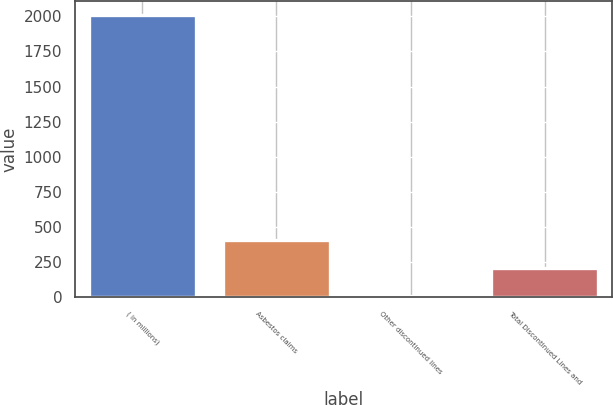Convert chart. <chart><loc_0><loc_0><loc_500><loc_500><bar_chart><fcel>( in millions)<fcel>Asbestos claims<fcel>Other discontinued lines<fcel>Total Discontinued Lines and<nl><fcel>2011<fcel>406.2<fcel>5<fcel>205.6<nl></chart> 